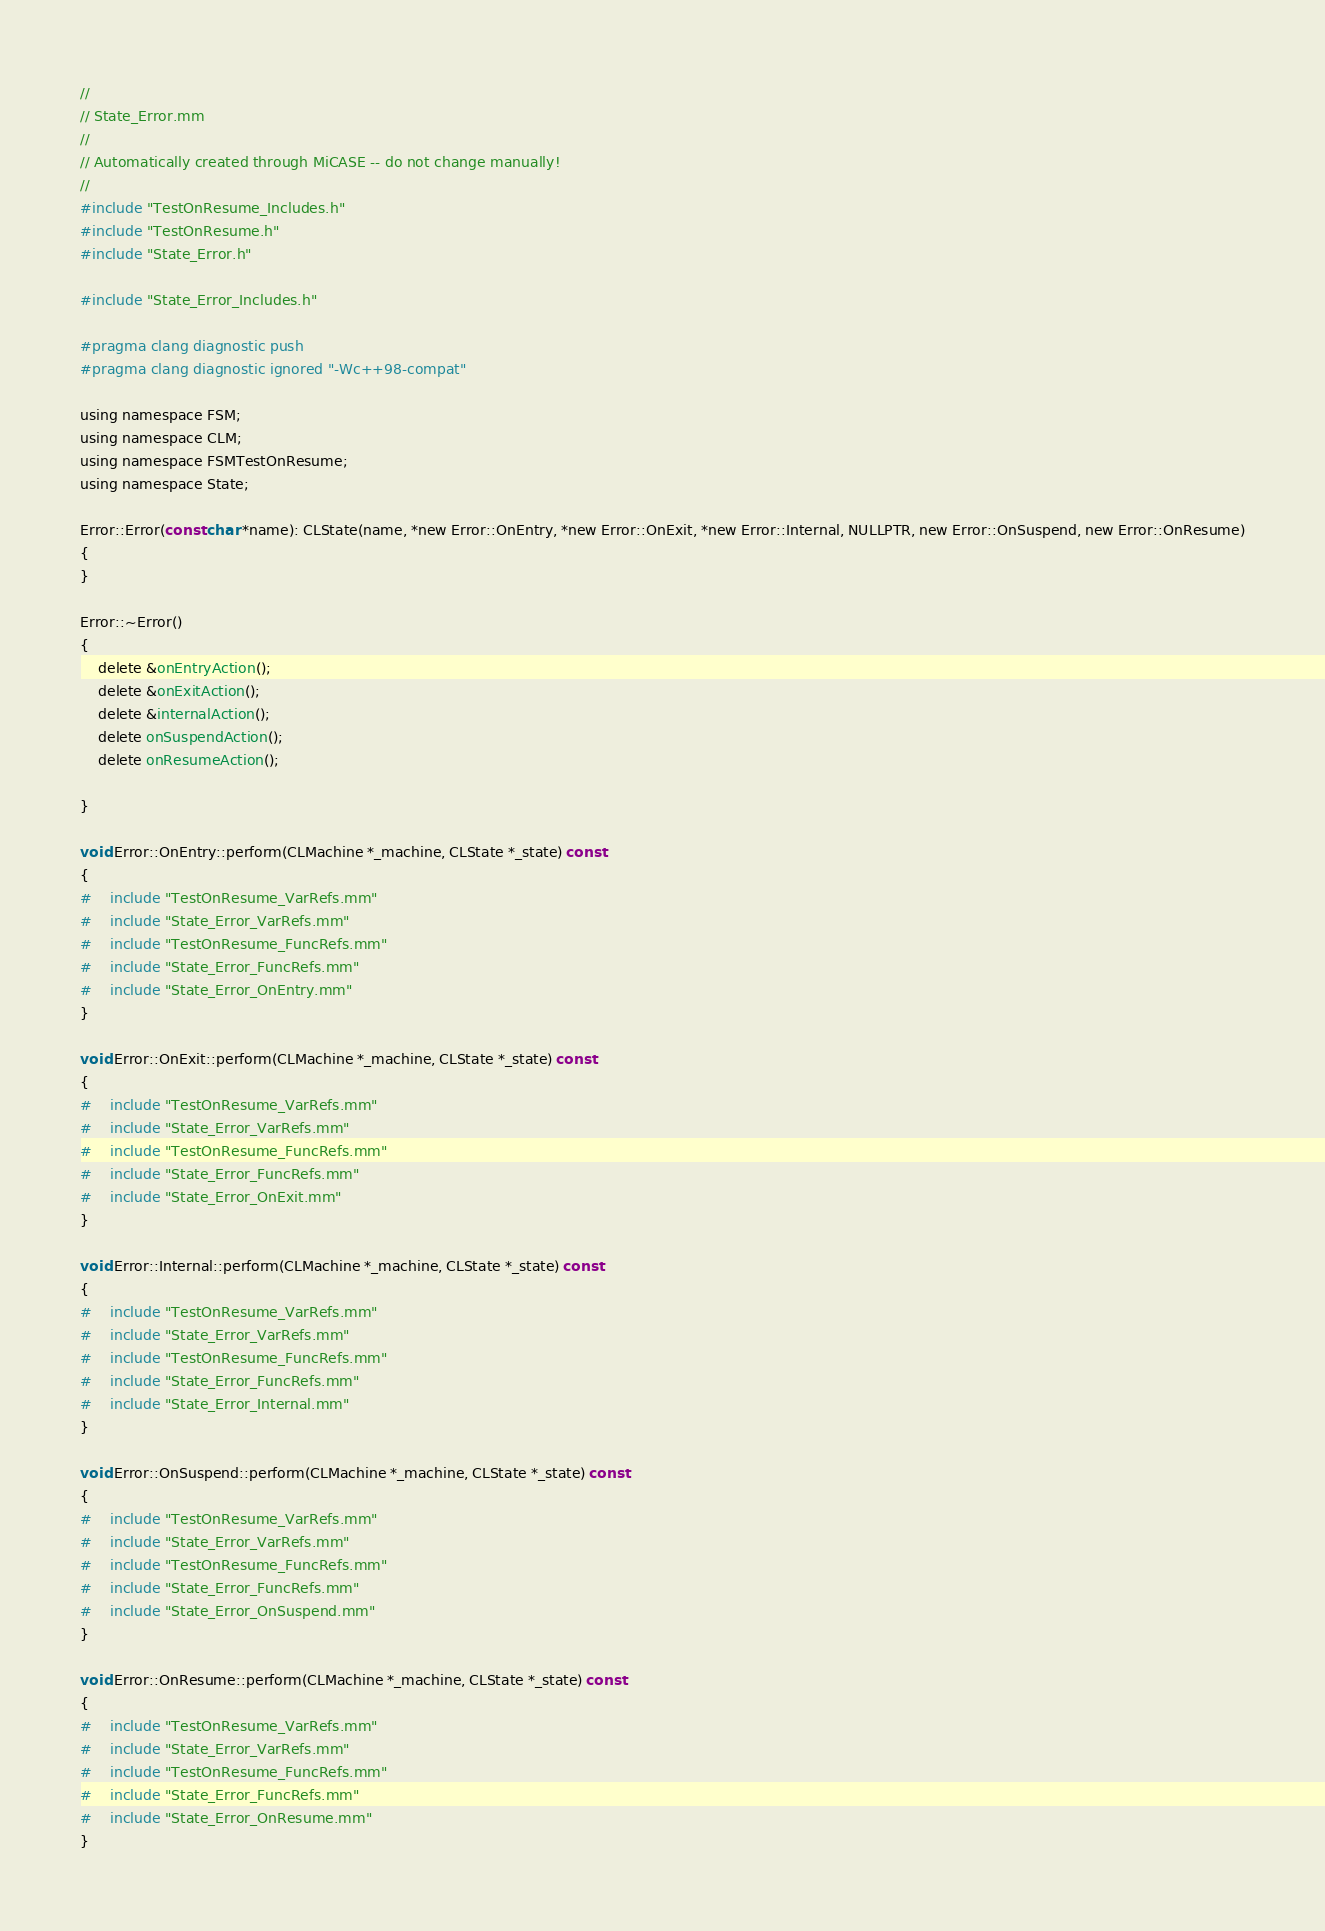Convert code to text. <code><loc_0><loc_0><loc_500><loc_500><_ObjectiveC_>//
// State_Error.mm
//
// Automatically created through MiCASE -- do not change manually!
//
#include "TestOnResume_Includes.h"
#include "TestOnResume.h"
#include "State_Error.h"

#include "State_Error_Includes.h"

#pragma clang diagnostic push
#pragma clang diagnostic ignored "-Wc++98-compat"

using namespace FSM;
using namespace CLM;
using namespace FSMTestOnResume;
using namespace State;

Error::Error(const char *name): CLState(name, *new Error::OnEntry, *new Error::OnExit, *new Error::Internal, NULLPTR, new Error::OnSuspend, new Error::OnResume)
{
}

Error::~Error()
{
	delete &onEntryAction();
	delete &onExitAction();
	delete &internalAction();
	delete onSuspendAction();
	delete onResumeAction();

}

void Error::OnEntry::perform(CLMachine *_machine, CLState *_state) const
{
#	include "TestOnResume_VarRefs.mm"
#	include "State_Error_VarRefs.mm"
#	include "TestOnResume_FuncRefs.mm"
#	include "State_Error_FuncRefs.mm"
#	include "State_Error_OnEntry.mm"
}

void Error::OnExit::perform(CLMachine *_machine, CLState *_state) const
{
#	include "TestOnResume_VarRefs.mm"
#	include "State_Error_VarRefs.mm"
#	include "TestOnResume_FuncRefs.mm"
#	include "State_Error_FuncRefs.mm"
#	include "State_Error_OnExit.mm"
}

void Error::Internal::perform(CLMachine *_machine, CLState *_state) const
{
#	include "TestOnResume_VarRefs.mm"
#	include "State_Error_VarRefs.mm"
#	include "TestOnResume_FuncRefs.mm"
#	include "State_Error_FuncRefs.mm"
#	include "State_Error_Internal.mm"
}

void Error::OnSuspend::perform(CLMachine *_machine, CLState *_state) const
{
#	include "TestOnResume_VarRefs.mm"
#	include "State_Error_VarRefs.mm"
#	include "TestOnResume_FuncRefs.mm"
#	include "State_Error_FuncRefs.mm"
#	include "State_Error_OnSuspend.mm"
}

void Error::OnResume::perform(CLMachine *_machine, CLState *_state) const
{
#	include "TestOnResume_VarRefs.mm"
#	include "State_Error_VarRefs.mm"
#	include "TestOnResume_FuncRefs.mm"
#	include "State_Error_FuncRefs.mm"
#	include "State_Error_OnResume.mm"
}
</code> 